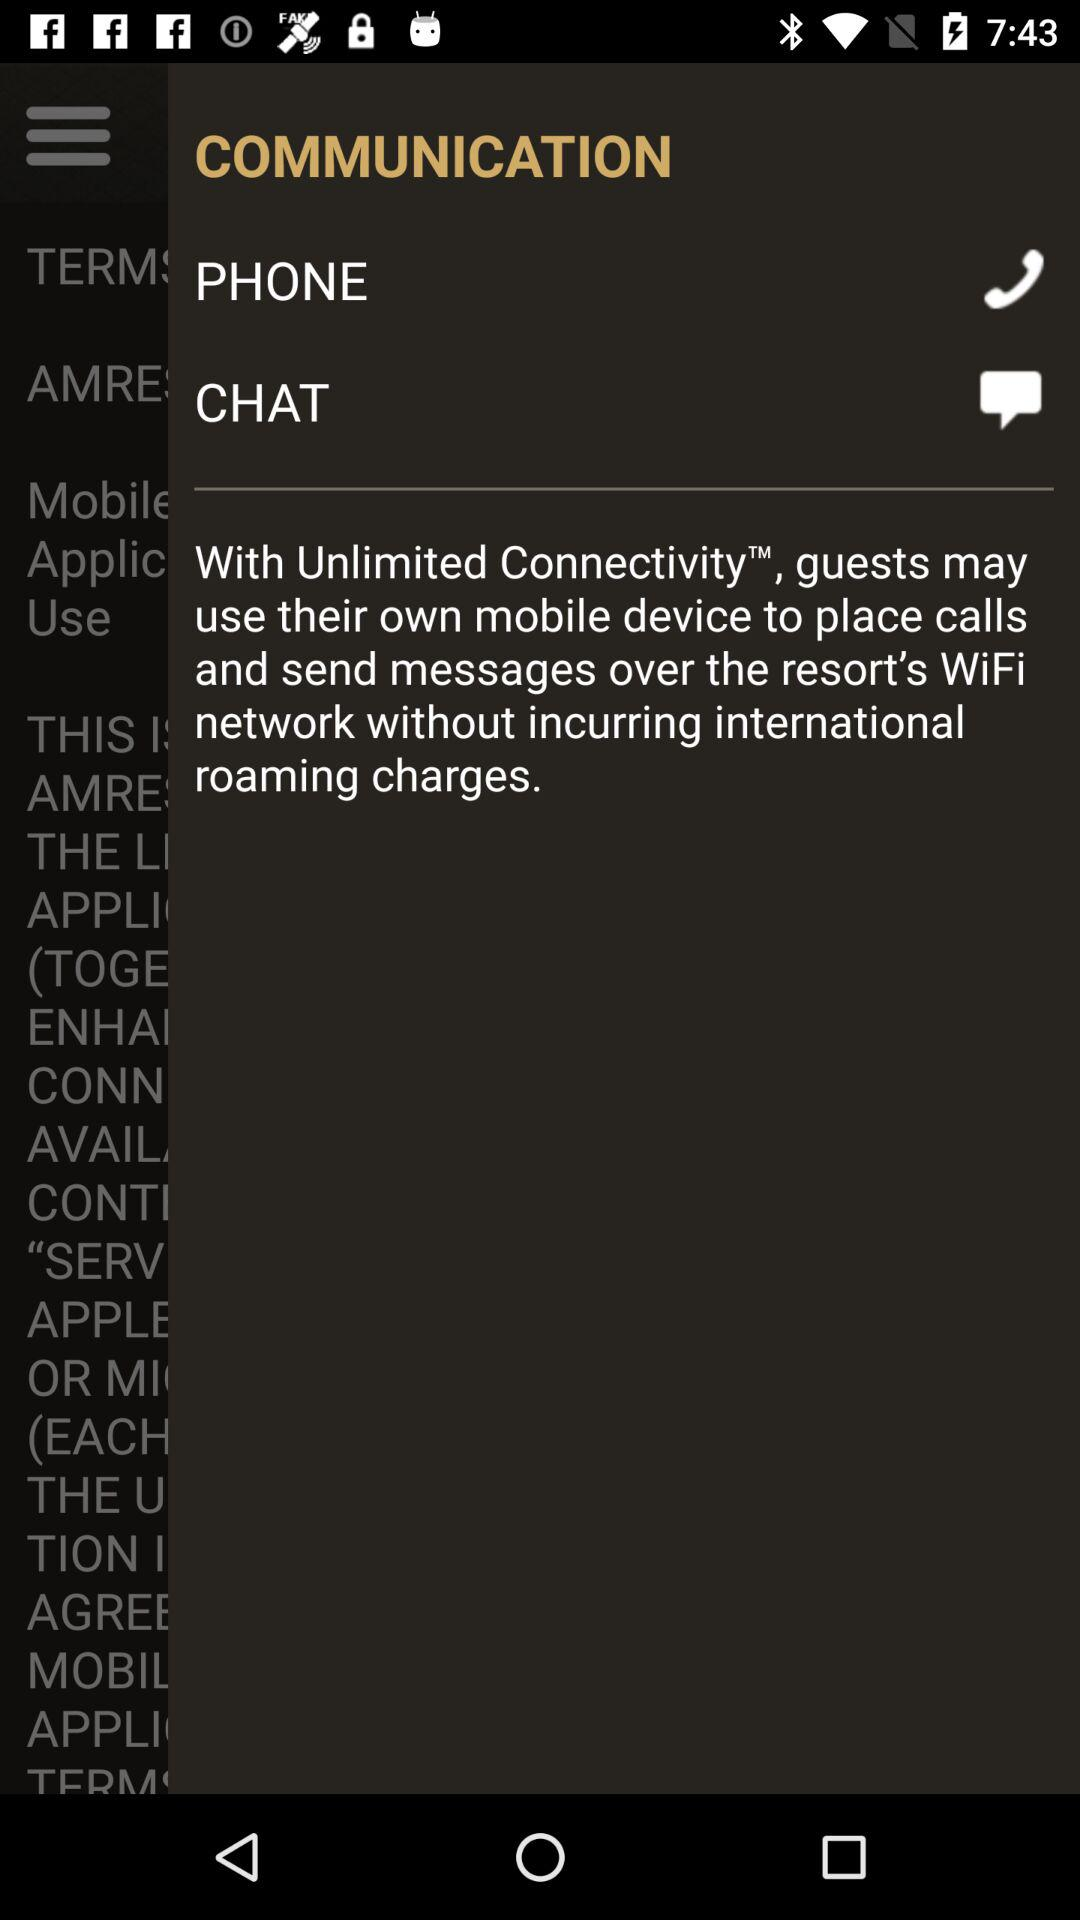What are the ways of communication? The ways of communication are phone and chat. 